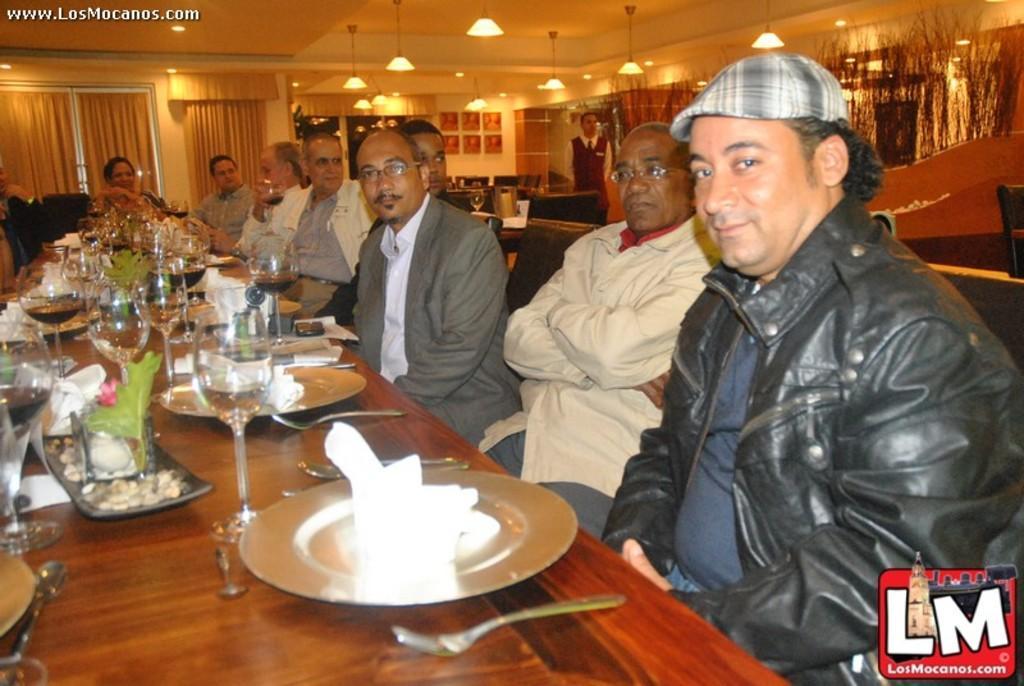Describe this image in one or two sentences. In this picture we can see a group of people sitting on chairs and in front of them we can see plates, glasses, forks, tissue papers and some objects on the table and in the background we can see windows with curtains, frames on the wall, plants and a man standing. 